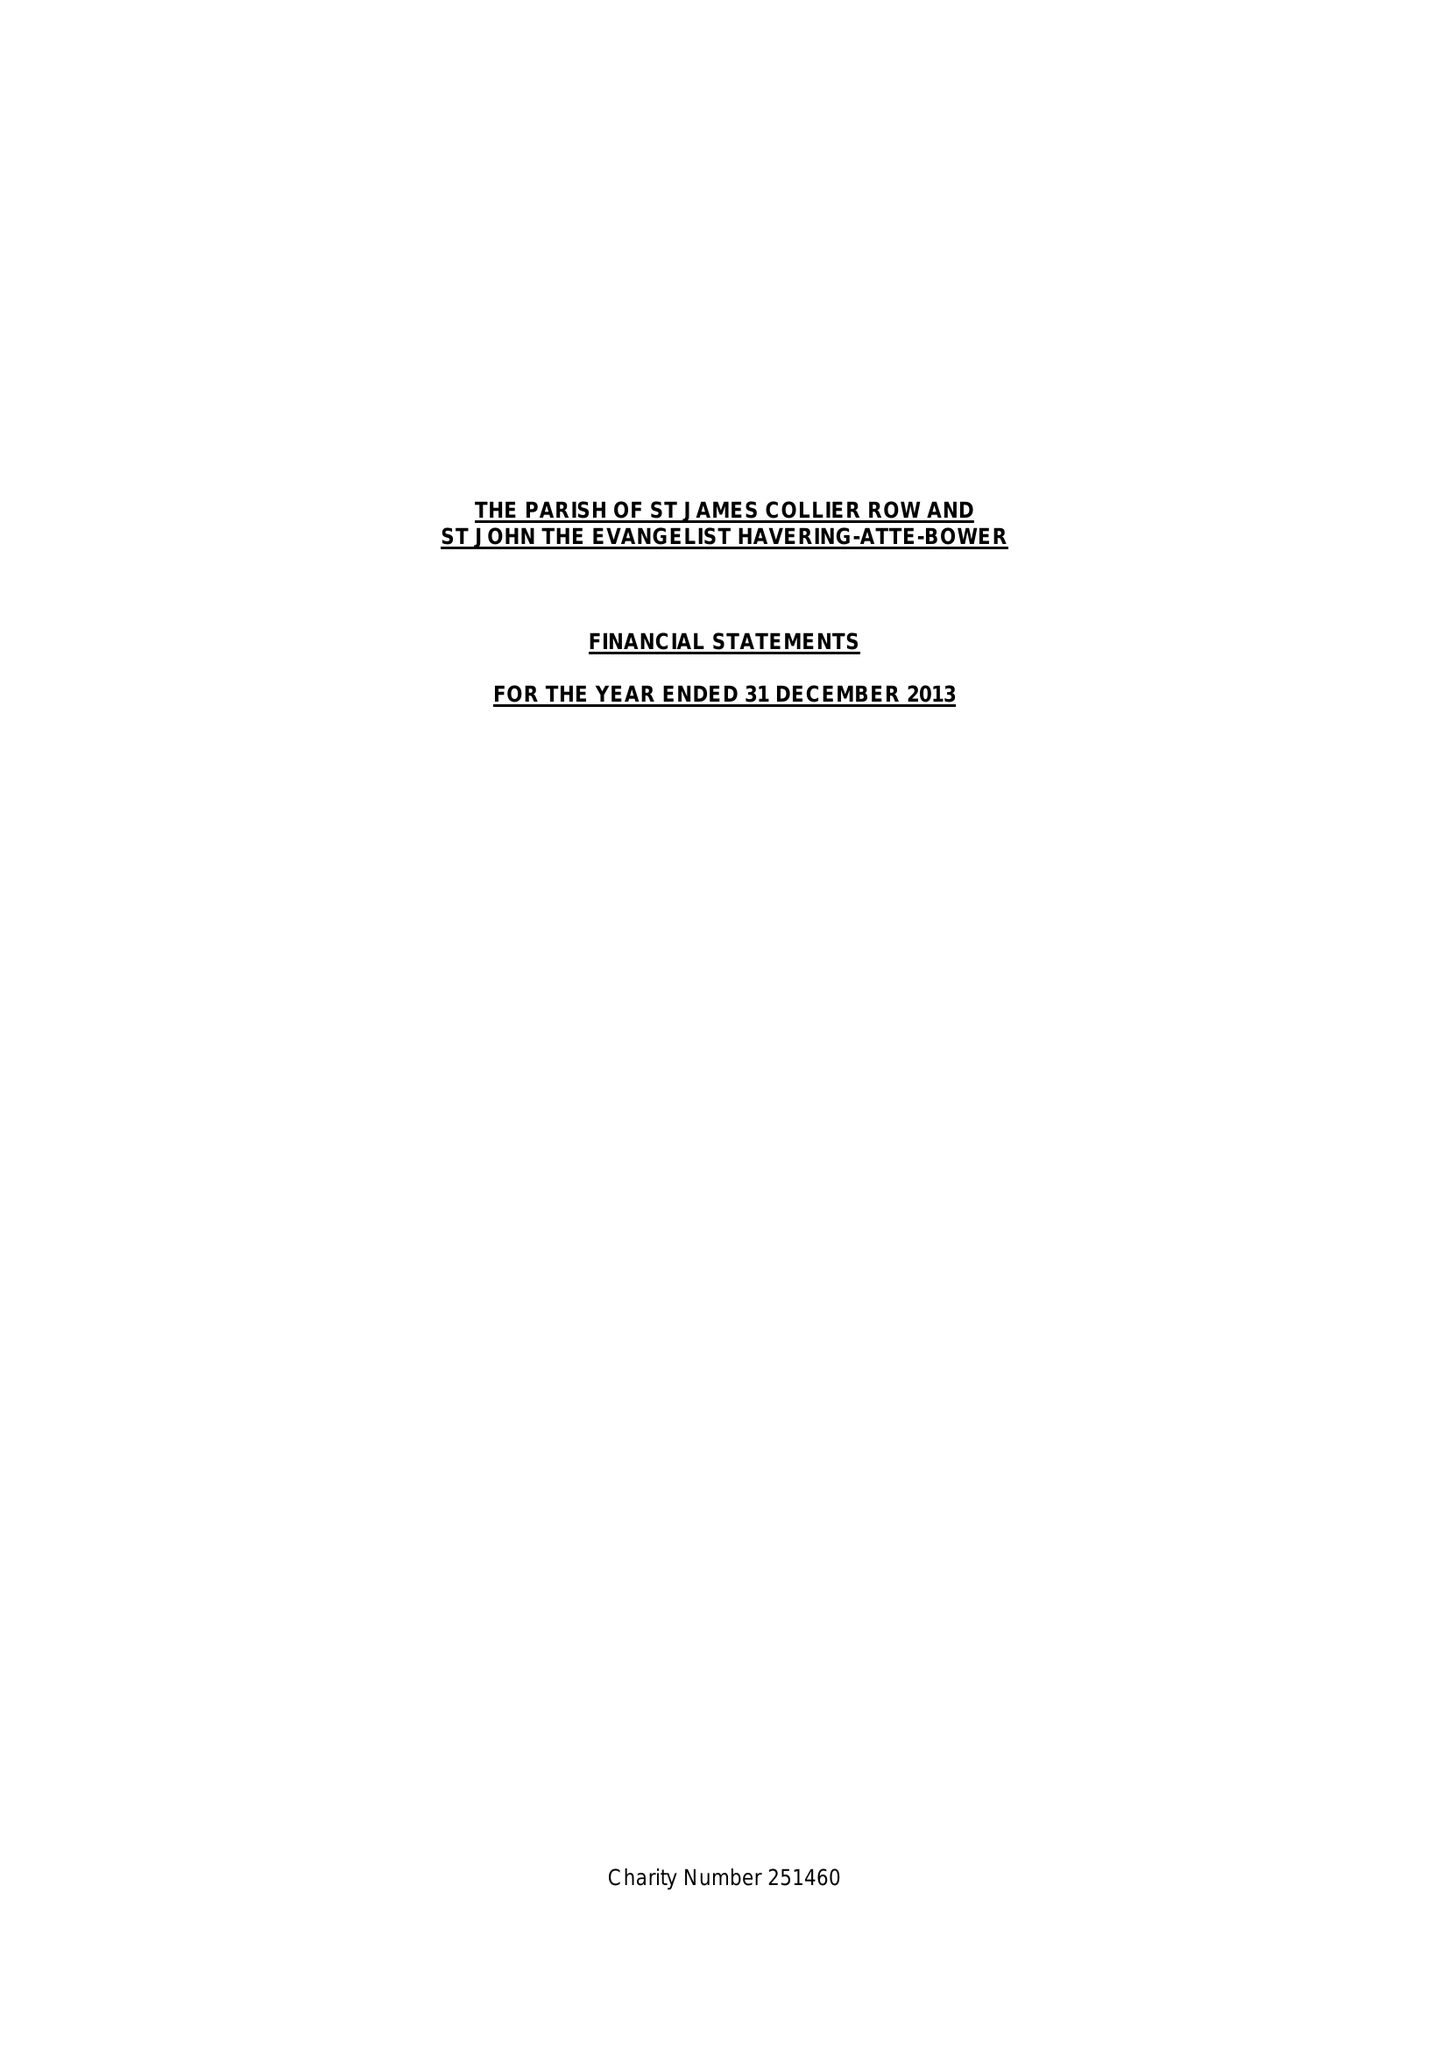What is the value for the charity_name?
Answer the question using a single word or phrase. The Parish Of Saint James Collier Row and Saint John Havering-Atte-Bower 